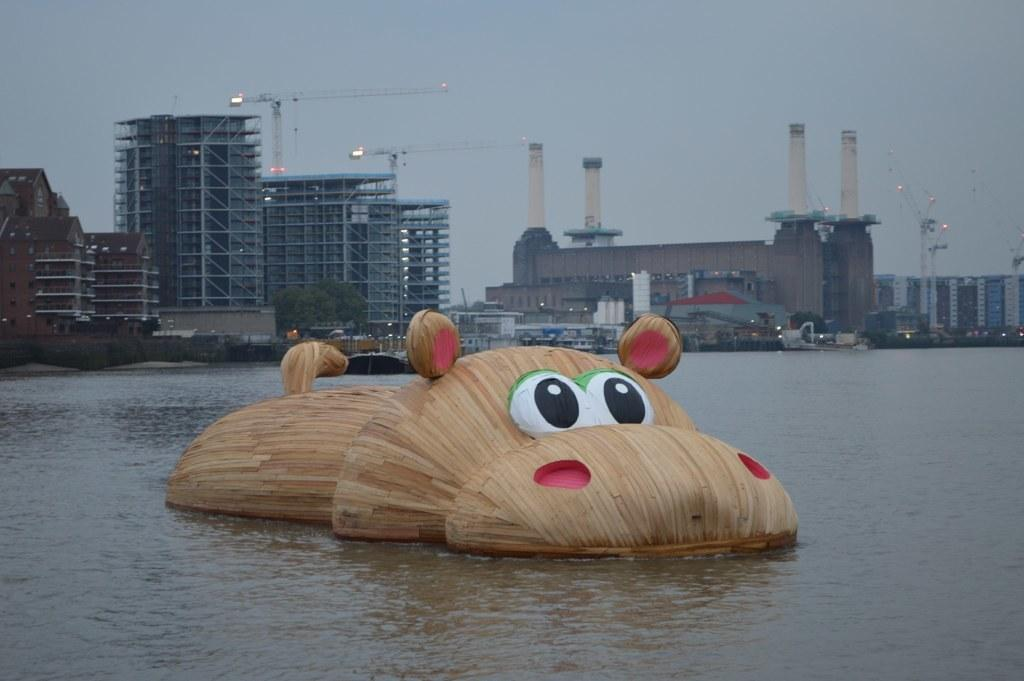What is in the water in the foreground of the picture? There is a wooden hippopotamus in the water in the foreground of the picture. What can be seen in the background of the picture? There are buildings, trees, lights, and cranes in the background of the picture. What is the condition of the sky in the picture? The sky is cloudy in the picture. Can you tell me how many receipts are visible in the picture? There are no receipts present in the picture. What type of ear can be seen on the wooden hippopotamus in the image? The wooden hippopotamus in the image does not have an ear, as it is a sculpture and not a living creature. 